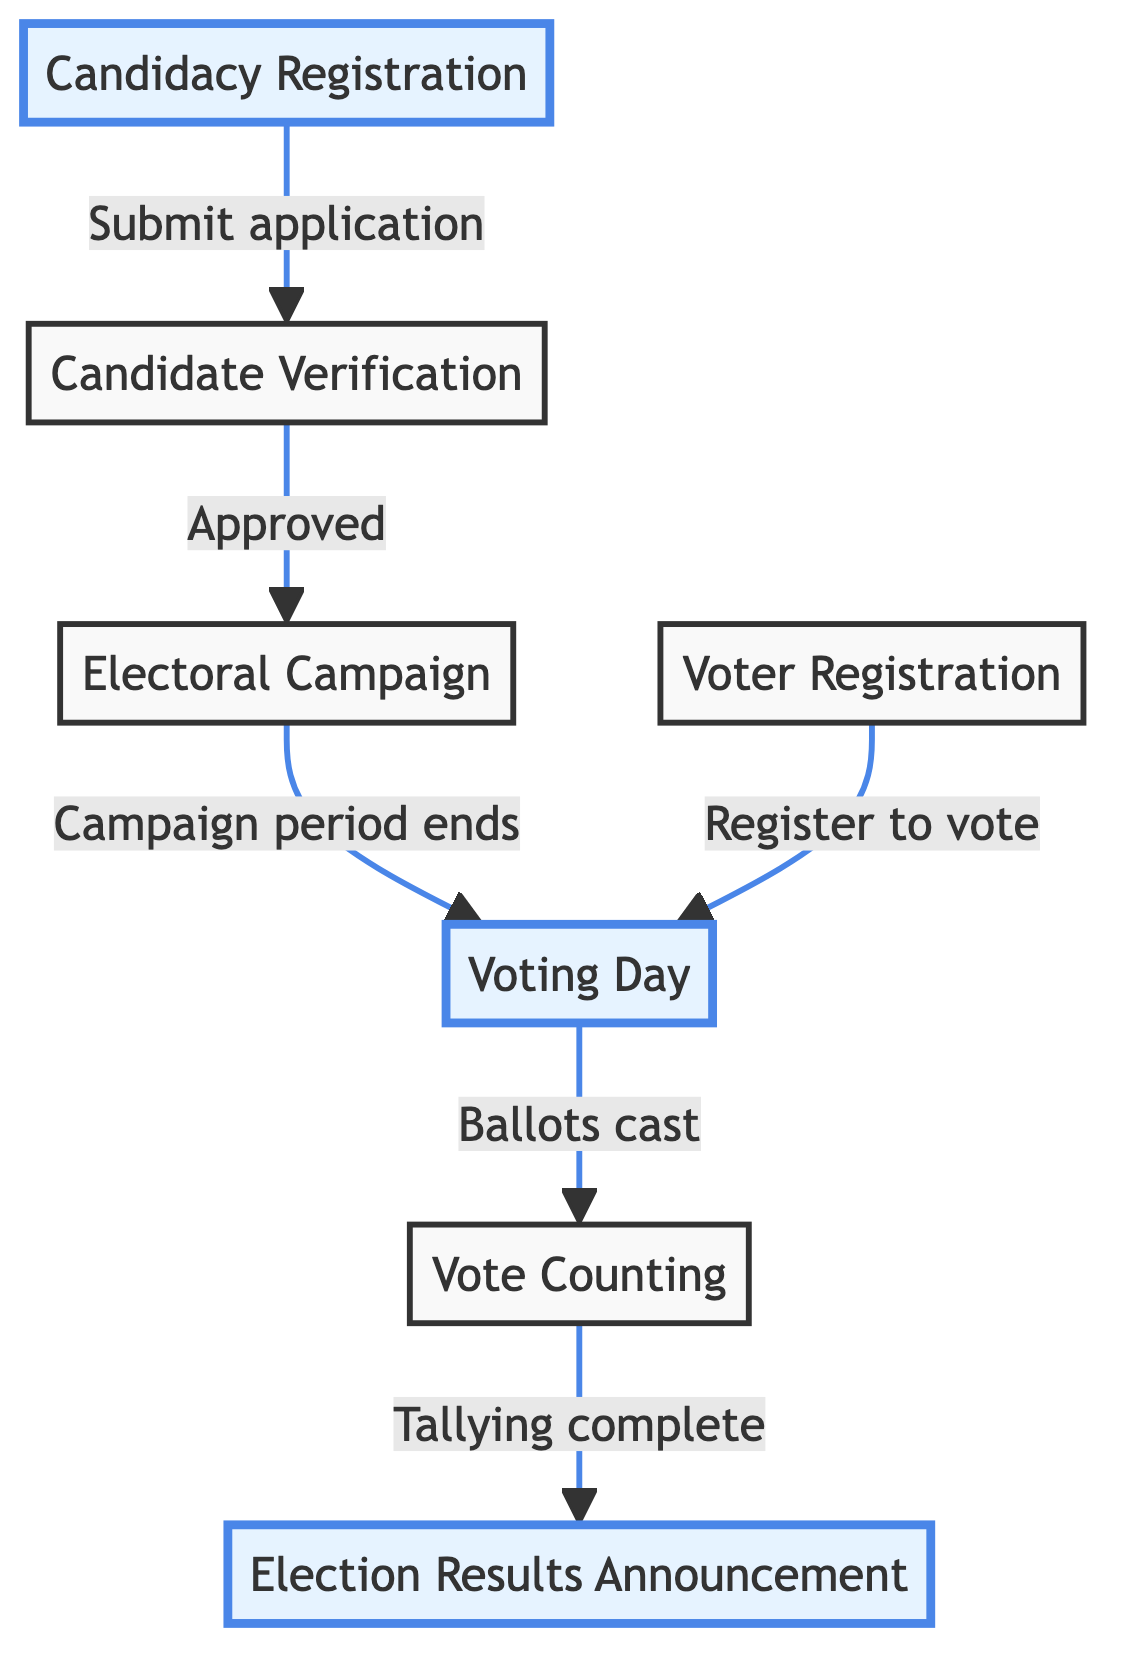What is the first step in the electoral process? The diagram shows "Candidacy Registration" as the first node, indicating that it is the initial step candidates must take.
Answer: Candidacy Registration How many main steps are depicted in the flow chart? By counting the nodes in the diagram, we can identify that there are a total of seven main steps or nodes.
Answer: Seven What action follows candidate verification? The flow indicates that after candidate verification, candidates move on to "Electoral Campaign" to engage with voters.
Answer: Electoral Campaign What happens on "Voting Day"? According to the diagram, registered voters cast their ballots at designated polling stations on Voting Day.
Answer: Cast ballots What is the final outcome indicated in the diagram? The last step shown is "Election Results Announcement," which concludes the electoral process by declaring the official results and elected candidates.
Answer: Election Results Announcement Which two steps are highlighted in the flow chart? The highlighted nodes in the diagram are "Candidacy Registration" and "Voting Day," indicating key stages in the process.
Answer: Candidacy Registration and Voting Day What must eligible citizens do before voting? The diagram specifies that eligible citizens must go through "Voter Registration" to be able to vote.
Answer: Voter Registration What is done after votes are counted? After the counting of votes is completed, the next step in the flow is to announce the results, as indicated by the arrow leading to "Election Results Announcement."
Answer: Announce results 